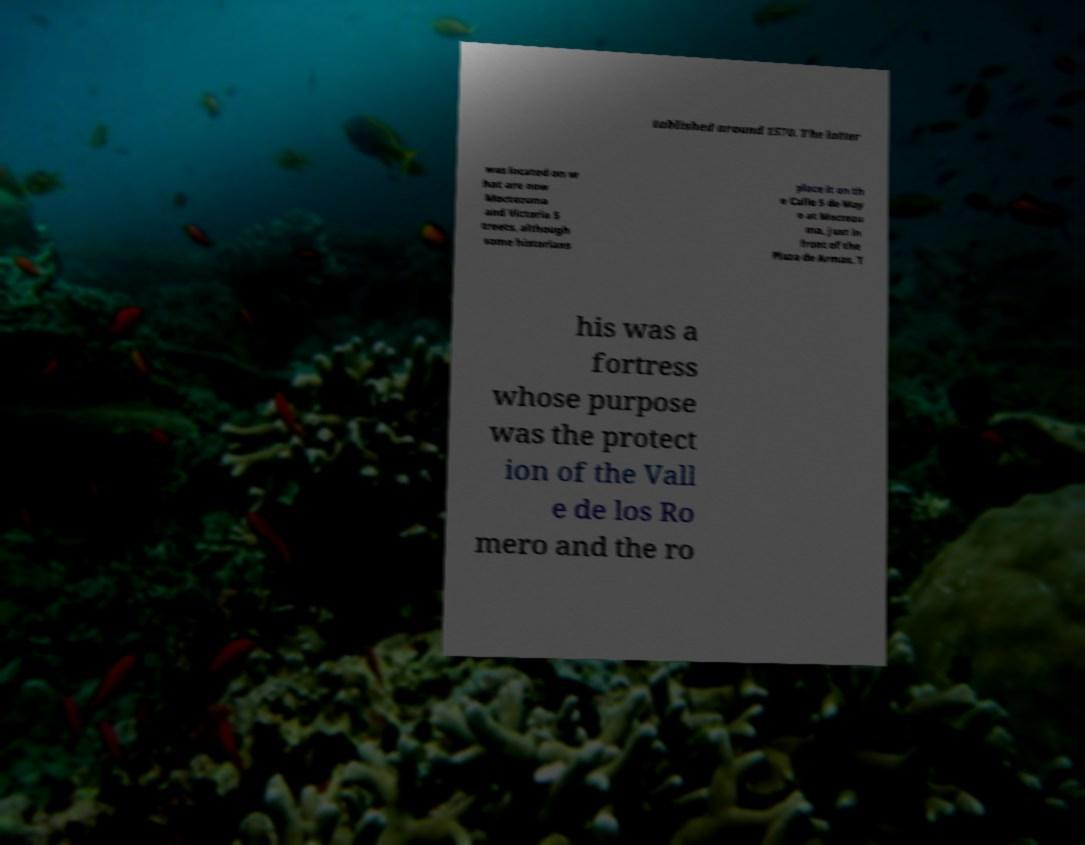What messages or text are displayed in this image? I need them in a readable, typed format. tablished around 1570. The latter was located on w hat are now Moctezuma and Victoria S treets, although some historians place it on th e Calle 5 de May o at Moctezu ma, just in front of the Plaza de Armas. T his was a fortress whose purpose was the protect ion of the Vall e de los Ro mero and the ro 